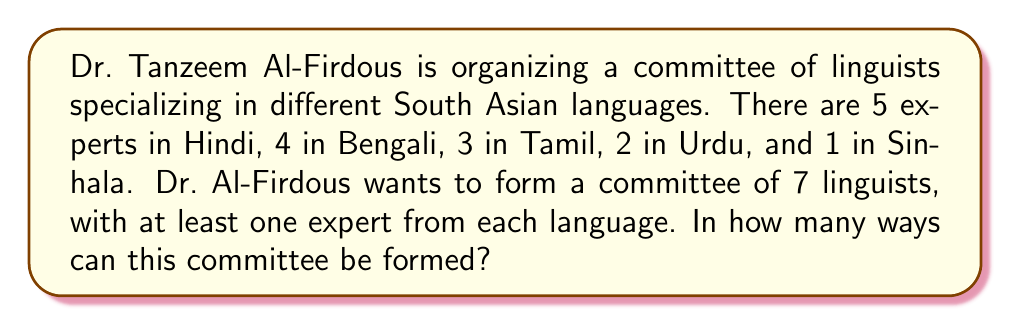What is the answer to this math problem? Let's approach this step-by-step using the multiplication principle and combinations:

1) First, we need to select one expert from each language to ensure representation:
   - 1 from Hindi, 1 from Bengali, 1 from Tamil, 1 from Urdu, and 1 from Sinhala
   This leaves 2 more spots to fill.

2) Now, we have:
   - 4 Hindi experts left (5 - 1)
   - 3 Bengali experts left (4 - 1)
   - 2 Tamil experts left (3 - 1)
   - 1 Urdu expert left (2 - 1)
   - 0 Sinhala experts left (1 - 1)

3) We need to choose 2 more experts from the remaining 10 (4 + 3 + 2 + 1) experts.
   This can be done in $\binom{10}{2}$ ways.

4) By the multiplication principle, the total number of ways to form the committee is:

   $$5 \cdot 4 \cdot 3 \cdot 2 \cdot 1 \cdot \binom{10}{2}$$

5) Simplify:
   $$120 \cdot \frac{10!}{2!(10-2)!} = 120 \cdot \frac{10 \cdot 9}{2} = 120 \cdot 45 = 5400$$

Therefore, the committee can be formed in 5400 different ways.
Answer: 5400 